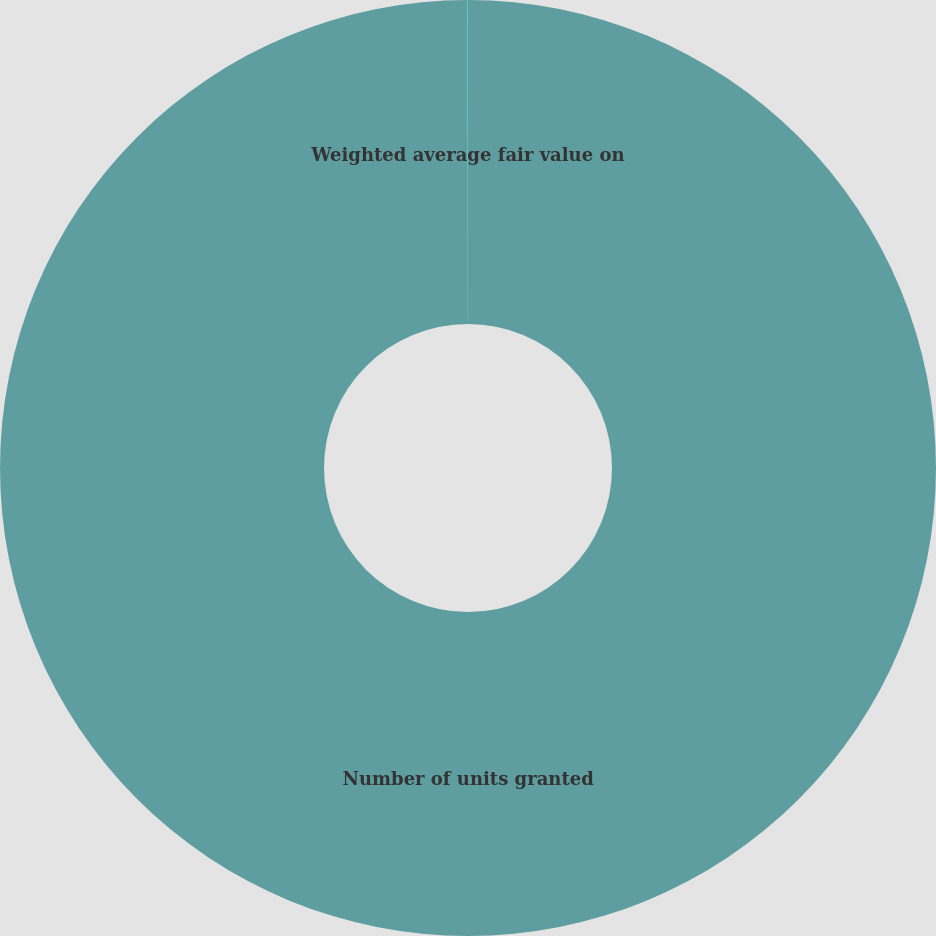<chart> <loc_0><loc_0><loc_500><loc_500><pie_chart><fcel>Number of units granted<fcel>Weighted average fair value on<nl><fcel>99.99%<fcel>0.01%<nl></chart> 